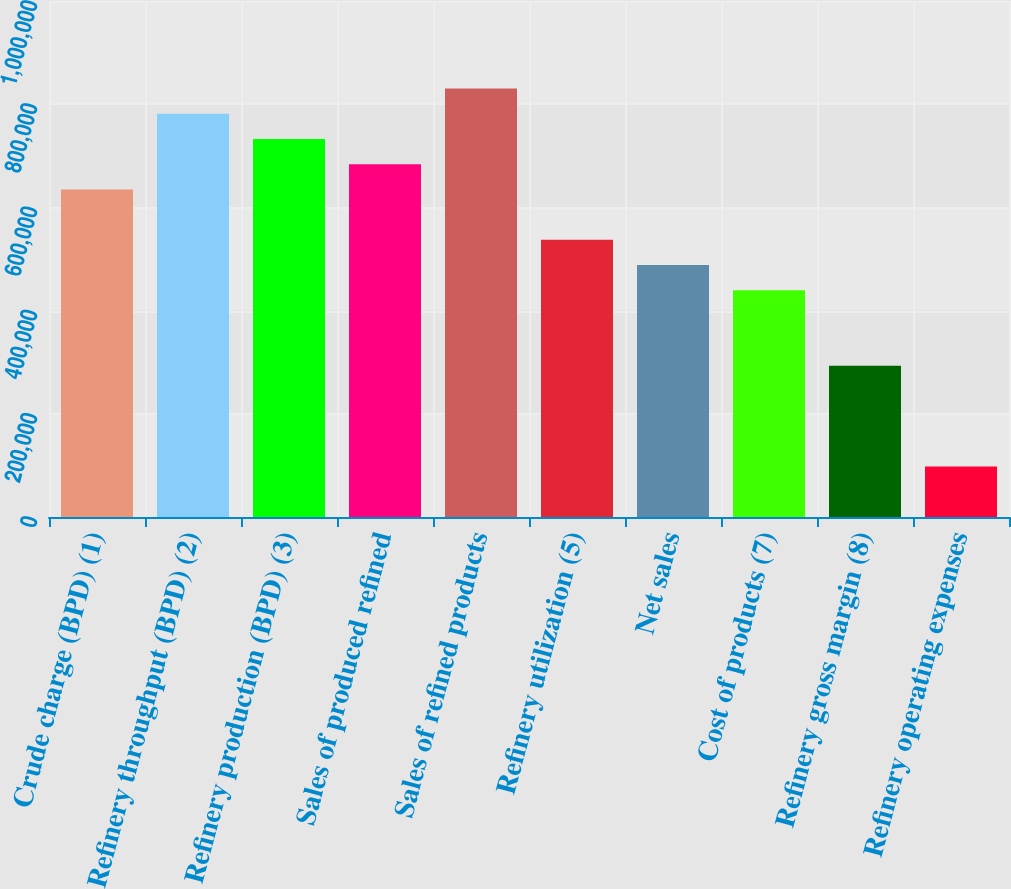Convert chart to OTSL. <chart><loc_0><loc_0><loc_500><loc_500><bar_chart><fcel>Crude charge (BPD) (1)<fcel>Refinery throughput (BPD) (2)<fcel>Refinery production (BPD) (3)<fcel>Sales of produced refined<fcel>Sales of refined products<fcel>Refinery utilization (5)<fcel>Net sales<fcel>Cost of products (7)<fcel>Refinery gross margin (8)<fcel>Refinery operating expenses<nl><fcel>634854<fcel>781359<fcel>732524<fcel>683689<fcel>830194<fcel>537185<fcel>488350<fcel>439515<fcel>293011<fcel>97671.6<nl></chart> 